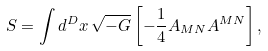<formula> <loc_0><loc_0><loc_500><loc_500>S = \int d ^ { D } x \, \sqrt { - G } \left [ - \frac { 1 } { 4 } A _ { M N } A ^ { M N } \right ] ,</formula> 